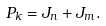<formula> <loc_0><loc_0><loc_500><loc_500>P _ { k } = J _ { n } + J _ { m } .</formula> 